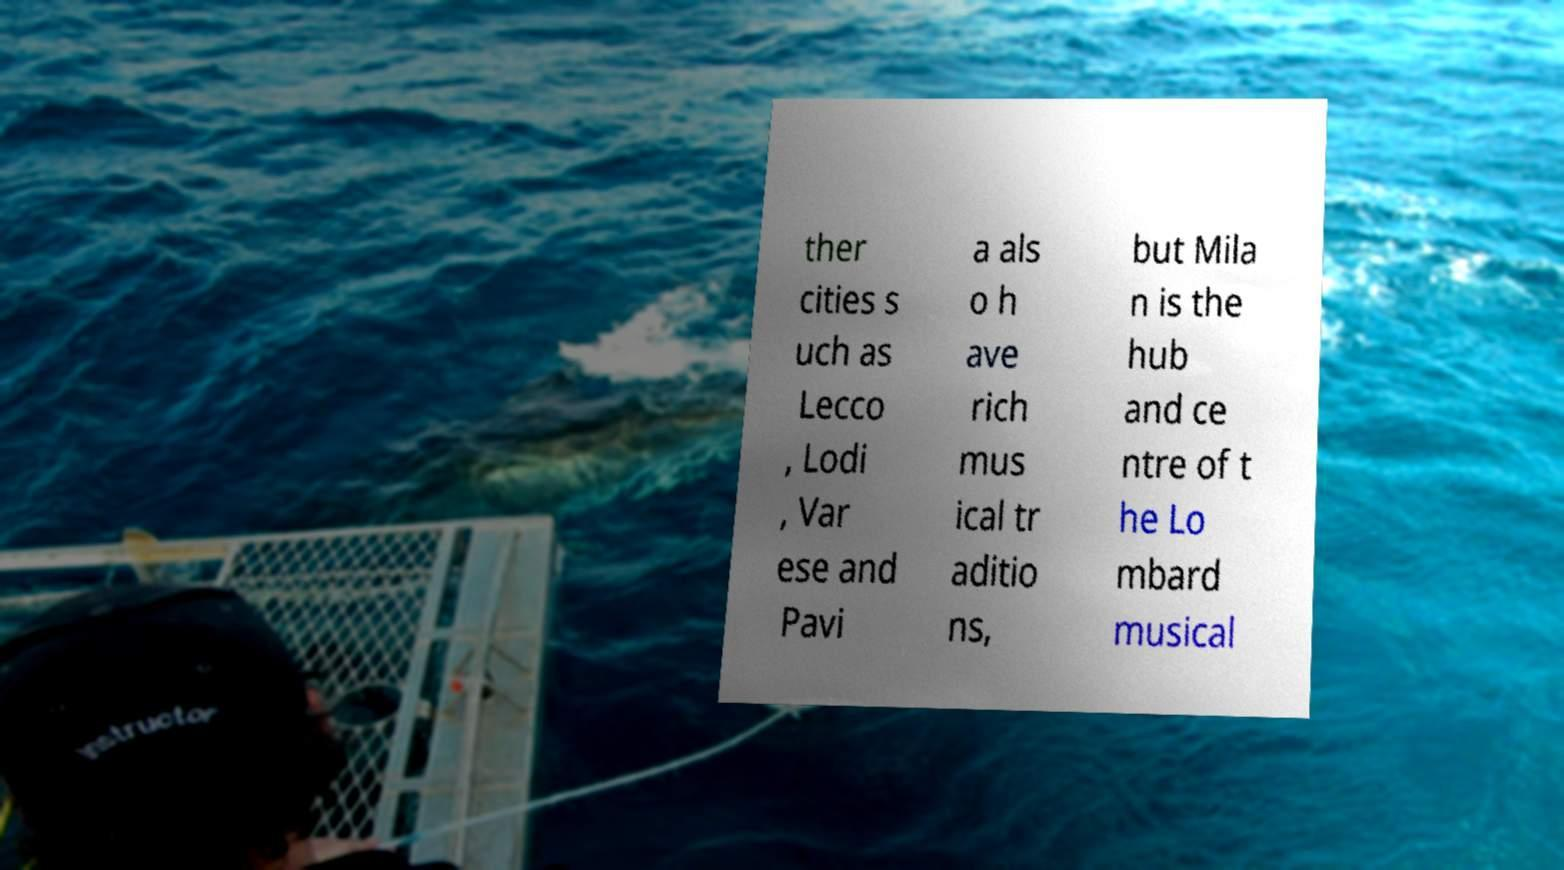Please read and relay the text visible in this image. What does it say? ther cities s uch as Lecco , Lodi , Var ese and Pavi a als o h ave rich mus ical tr aditio ns, but Mila n is the hub and ce ntre of t he Lo mbard musical 